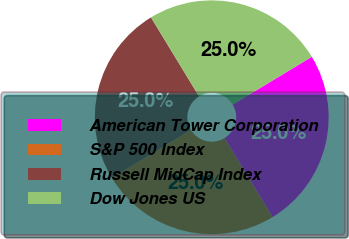Convert chart. <chart><loc_0><loc_0><loc_500><loc_500><pie_chart><fcel>American Tower Corporation<fcel>S&P 500 Index<fcel>Russell MidCap Index<fcel>Dow Jones US<nl><fcel>24.96%<fcel>24.99%<fcel>25.01%<fcel>25.04%<nl></chart> 